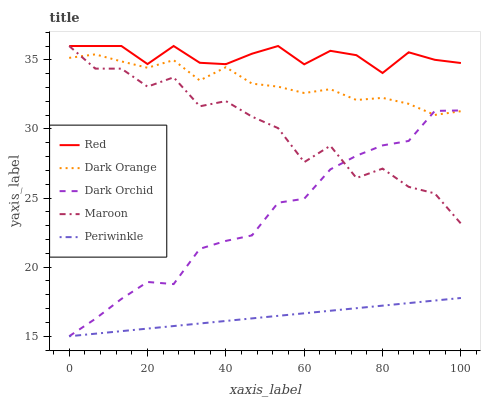Does Periwinkle have the minimum area under the curve?
Answer yes or no. Yes. Does Red have the maximum area under the curve?
Answer yes or no. Yes. Does Dark Orange have the minimum area under the curve?
Answer yes or no. No. Does Dark Orange have the maximum area under the curve?
Answer yes or no. No. Is Periwinkle the smoothest?
Answer yes or no. Yes. Is Maroon the roughest?
Answer yes or no. Yes. Is Dark Orange the smoothest?
Answer yes or no. No. Is Dark Orange the roughest?
Answer yes or no. No. Does Periwinkle have the lowest value?
Answer yes or no. Yes. Does Dark Orange have the lowest value?
Answer yes or no. No. Does Red have the highest value?
Answer yes or no. Yes. Does Dark Orange have the highest value?
Answer yes or no. No. Is Periwinkle less than Red?
Answer yes or no. Yes. Is Maroon greater than Periwinkle?
Answer yes or no. Yes. Does Dark Orchid intersect Dark Orange?
Answer yes or no. Yes. Is Dark Orchid less than Dark Orange?
Answer yes or no. No. Is Dark Orchid greater than Dark Orange?
Answer yes or no. No. Does Periwinkle intersect Red?
Answer yes or no. No. 